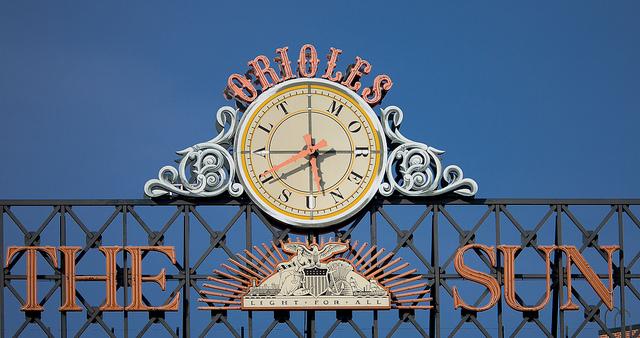What is cast?
Concise answer only. Shadow. What time is it?
Be succinct. 5:40. What sport is this for?
Write a very short answer. Baseball. 